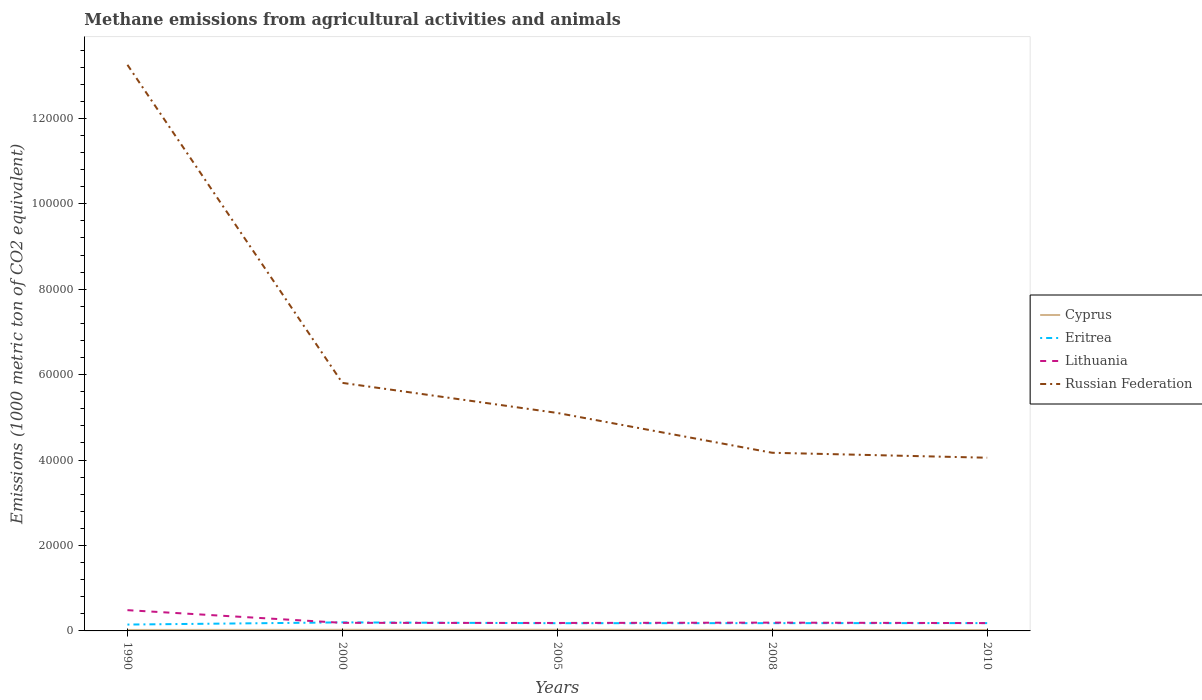Does the line corresponding to Russian Federation intersect with the line corresponding to Cyprus?
Your response must be concise. No. Is the number of lines equal to the number of legend labels?
Your response must be concise. Yes. Across all years, what is the maximum amount of methane emitted in Lithuania?
Keep it short and to the point. 1832.4. What is the total amount of methane emitted in Lithuania in the graph?
Provide a succinct answer. 31.6. What is the difference between the highest and the second highest amount of methane emitted in Cyprus?
Provide a short and direct response. 53.4. Is the amount of methane emitted in Cyprus strictly greater than the amount of methane emitted in Russian Federation over the years?
Offer a terse response. Yes. What is the difference between two consecutive major ticks on the Y-axis?
Give a very brief answer. 2.00e+04. Are the values on the major ticks of Y-axis written in scientific E-notation?
Offer a terse response. No. Does the graph contain any zero values?
Keep it short and to the point. No. Where does the legend appear in the graph?
Offer a very short reply. Center right. How are the legend labels stacked?
Provide a short and direct response. Vertical. What is the title of the graph?
Offer a terse response. Methane emissions from agricultural activities and animals. What is the label or title of the Y-axis?
Make the answer very short. Emissions (1000 metric ton of CO2 equivalent). What is the Emissions (1000 metric ton of CO2 equivalent) of Cyprus in 1990?
Keep it short and to the point. 225.1. What is the Emissions (1000 metric ton of CO2 equivalent) of Eritrea in 1990?
Provide a succinct answer. 1488.1. What is the Emissions (1000 metric ton of CO2 equivalent) in Lithuania in 1990?
Ensure brevity in your answer.  4861.3. What is the Emissions (1000 metric ton of CO2 equivalent) in Russian Federation in 1990?
Your answer should be compact. 1.33e+05. What is the Emissions (1000 metric ton of CO2 equivalent) in Cyprus in 2000?
Your answer should be very brief. 261.7. What is the Emissions (1000 metric ton of CO2 equivalent) of Eritrea in 2000?
Your answer should be compact. 2000.3. What is the Emissions (1000 metric ton of CO2 equivalent) in Lithuania in 2000?
Offer a terse response. 1892.9. What is the Emissions (1000 metric ton of CO2 equivalent) in Russian Federation in 2000?
Give a very brief answer. 5.81e+04. What is the Emissions (1000 metric ton of CO2 equivalent) of Cyprus in 2005?
Your answer should be compact. 271. What is the Emissions (1000 metric ton of CO2 equivalent) of Eritrea in 2005?
Make the answer very short. 1806.6. What is the Emissions (1000 metric ton of CO2 equivalent) of Lithuania in 2005?
Your answer should be compact. 1864. What is the Emissions (1000 metric ton of CO2 equivalent) in Russian Federation in 2005?
Keep it short and to the point. 5.10e+04. What is the Emissions (1000 metric ton of CO2 equivalent) in Cyprus in 2008?
Provide a short and direct response. 231.7. What is the Emissions (1000 metric ton of CO2 equivalent) in Eritrea in 2008?
Offer a very short reply. 1820.8. What is the Emissions (1000 metric ton of CO2 equivalent) of Lithuania in 2008?
Make the answer very short. 1942.5. What is the Emissions (1000 metric ton of CO2 equivalent) in Russian Federation in 2008?
Offer a terse response. 4.17e+04. What is the Emissions (1000 metric ton of CO2 equivalent) of Cyprus in 2010?
Your response must be concise. 217.6. What is the Emissions (1000 metric ton of CO2 equivalent) of Eritrea in 2010?
Give a very brief answer. 1829.8. What is the Emissions (1000 metric ton of CO2 equivalent) of Lithuania in 2010?
Offer a very short reply. 1832.4. What is the Emissions (1000 metric ton of CO2 equivalent) of Russian Federation in 2010?
Your answer should be very brief. 4.06e+04. Across all years, what is the maximum Emissions (1000 metric ton of CO2 equivalent) of Cyprus?
Give a very brief answer. 271. Across all years, what is the maximum Emissions (1000 metric ton of CO2 equivalent) in Eritrea?
Keep it short and to the point. 2000.3. Across all years, what is the maximum Emissions (1000 metric ton of CO2 equivalent) in Lithuania?
Keep it short and to the point. 4861.3. Across all years, what is the maximum Emissions (1000 metric ton of CO2 equivalent) in Russian Federation?
Make the answer very short. 1.33e+05. Across all years, what is the minimum Emissions (1000 metric ton of CO2 equivalent) in Cyprus?
Offer a very short reply. 217.6. Across all years, what is the minimum Emissions (1000 metric ton of CO2 equivalent) in Eritrea?
Offer a terse response. 1488.1. Across all years, what is the minimum Emissions (1000 metric ton of CO2 equivalent) in Lithuania?
Your answer should be very brief. 1832.4. Across all years, what is the minimum Emissions (1000 metric ton of CO2 equivalent) of Russian Federation?
Ensure brevity in your answer.  4.06e+04. What is the total Emissions (1000 metric ton of CO2 equivalent) in Cyprus in the graph?
Your answer should be very brief. 1207.1. What is the total Emissions (1000 metric ton of CO2 equivalent) of Eritrea in the graph?
Offer a terse response. 8945.6. What is the total Emissions (1000 metric ton of CO2 equivalent) of Lithuania in the graph?
Your answer should be very brief. 1.24e+04. What is the total Emissions (1000 metric ton of CO2 equivalent) of Russian Federation in the graph?
Keep it short and to the point. 3.24e+05. What is the difference between the Emissions (1000 metric ton of CO2 equivalent) in Cyprus in 1990 and that in 2000?
Provide a short and direct response. -36.6. What is the difference between the Emissions (1000 metric ton of CO2 equivalent) in Eritrea in 1990 and that in 2000?
Offer a terse response. -512.2. What is the difference between the Emissions (1000 metric ton of CO2 equivalent) of Lithuania in 1990 and that in 2000?
Offer a very short reply. 2968.4. What is the difference between the Emissions (1000 metric ton of CO2 equivalent) of Russian Federation in 1990 and that in 2000?
Give a very brief answer. 7.45e+04. What is the difference between the Emissions (1000 metric ton of CO2 equivalent) of Cyprus in 1990 and that in 2005?
Give a very brief answer. -45.9. What is the difference between the Emissions (1000 metric ton of CO2 equivalent) of Eritrea in 1990 and that in 2005?
Offer a very short reply. -318.5. What is the difference between the Emissions (1000 metric ton of CO2 equivalent) in Lithuania in 1990 and that in 2005?
Your response must be concise. 2997.3. What is the difference between the Emissions (1000 metric ton of CO2 equivalent) in Russian Federation in 1990 and that in 2005?
Your answer should be very brief. 8.15e+04. What is the difference between the Emissions (1000 metric ton of CO2 equivalent) of Eritrea in 1990 and that in 2008?
Provide a short and direct response. -332.7. What is the difference between the Emissions (1000 metric ton of CO2 equivalent) of Lithuania in 1990 and that in 2008?
Make the answer very short. 2918.8. What is the difference between the Emissions (1000 metric ton of CO2 equivalent) in Russian Federation in 1990 and that in 2008?
Offer a very short reply. 9.08e+04. What is the difference between the Emissions (1000 metric ton of CO2 equivalent) of Cyprus in 1990 and that in 2010?
Give a very brief answer. 7.5. What is the difference between the Emissions (1000 metric ton of CO2 equivalent) of Eritrea in 1990 and that in 2010?
Keep it short and to the point. -341.7. What is the difference between the Emissions (1000 metric ton of CO2 equivalent) of Lithuania in 1990 and that in 2010?
Keep it short and to the point. 3028.9. What is the difference between the Emissions (1000 metric ton of CO2 equivalent) in Russian Federation in 1990 and that in 2010?
Your answer should be compact. 9.20e+04. What is the difference between the Emissions (1000 metric ton of CO2 equivalent) of Eritrea in 2000 and that in 2005?
Make the answer very short. 193.7. What is the difference between the Emissions (1000 metric ton of CO2 equivalent) in Lithuania in 2000 and that in 2005?
Ensure brevity in your answer.  28.9. What is the difference between the Emissions (1000 metric ton of CO2 equivalent) in Russian Federation in 2000 and that in 2005?
Give a very brief answer. 7040. What is the difference between the Emissions (1000 metric ton of CO2 equivalent) in Cyprus in 2000 and that in 2008?
Your response must be concise. 30. What is the difference between the Emissions (1000 metric ton of CO2 equivalent) of Eritrea in 2000 and that in 2008?
Ensure brevity in your answer.  179.5. What is the difference between the Emissions (1000 metric ton of CO2 equivalent) in Lithuania in 2000 and that in 2008?
Offer a very short reply. -49.6. What is the difference between the Emissions (1000 metric ton of CO2 equivalent) of Russian Federation in 2000 and that in 2008?
Provide a short and direct response. 1.64e+04. What is the difference between the Emissions (1000 metric ton of CO2 equivalent) of Cyprus in 2000 and that in 2010?
Make the answer very short. 44.1. What is the difference between the Emissions (1000 metric ton of CO2 equivalent) of Eritrea in 2000 and that in 2010?
Provide a short and direct response. 170.5. What is the difference between the Emissions (1000 metric ton of CO2 equivalent) in Lithuania in 2000 and that in 2010?
Give a very brief answer. 60.5. What is the difference between the Emissions (1000 metric ton of CO2 equivalent) in Russian Federation in 2000 and that in 2010?
Ensure brevity in your answer.  1.75e+04. What is the difference between the Emissions (1000 metric ton of CO2 equivalent) in Cyprus in 2005 and that in 2008?
Offer a very short reply. 39.3. What is the difference between the Emissions (1000 metric ton of CO2 equivalent) in Lithuania in 2005 and that in 2008?
Offer a very short reply. -78.5. What is the difference between the Emissions (1000 metric ton of CO2 equivalent) in Russian Federation in 2005 and that in 2008?
Your answer should be very brief. 9324.6. What is the difference between the Emissions (1000 metric ton of CO2 equivalent) in Cyprus in 2005 and that in 2010?
Provide a short and direct response. 53.4. What is the difference between the Emissions (1000 metric ton of CO2 equivalent) of Eritrea in 2005 and that in 2010?
Offer a very short reply. -23.2. What is the difference between the Emissions (1000 metric ton of CO2 equivalent) of Lithuania in 2005 and that in 2010?
Offer a very short reply. 31.6. What is the difference between the Emissions (1000 metric ton of CO2 equivalent) in Russian Federation in 2005 and that in 2010?
Make the answer very short. 1.05e+04. What is the difference between the Emissions (1000 metric ton of CO2 equivalent) of Lithuania in 2008 and that in 2010?
Your answer should be compact. 110.1. What is the difference between the Emissions (1000 metric ton of CO2 equivalent) in Russian Federation in 2008 and that in 2010?
Provide a short and direct response. 1158.2. What is the difference between the Emissions (1000 metric ton of CO2 equivalent) in Cyprus in 1990 and the Emissions (1000 metric ton of CO2 equivalent) in Eritrea in 2000?
Your answer should be very brief. -1775.2. What is the difference between the Emissions (1000 metric ton of CO2 equivalent) of Cyprus in 1990 and the Emissions (1000 metric ton of CO2 equivalent) of Lithuania in 2000?
Keep it short and to the point. -1667.8. What is the difference between the Emissions (1000 metric ton of CO2 equivalent) in Cyprus in 1990 and the Emissions (1000 metric ton of CO2 equivalent) in Russian Federation in 2000?
Your response must be concise. -5.79e+04. What is the difference between the Emissions (1000 metric ton of CO2 equivalent) of Eritrea in 1990 and the Emissions (1000 metric ton of CO2 equivalent) of Lithuania in 2000?
Ensure brevity in your answer.  -404.8. What is the difference between the Emissions (1000 metric ton of CO2 equivalent) of Eritrea in 1990 and the Emissions (1000 metric ton of CO2 equivalent) of Russian Federation in 2000?
Your response must be concise. -5.66e+04. What is the difference between the Emissions (1000 metric ton of CO2 equivalent) of Lithuania in 1990 and the Emissions (1000 metric ton of CO2 equivalent) of Russian Federation in 2000?
Your answer should be very brief. -5.32e+04. What is the difference between the Emissions (1000 metric ton of CO2 equivalent) of Cyprus in 1990 and the Emissions (1000 metric ton of CO2 equivalent) of Eritrea in 2005?
Keep it short and to the point. -1581.5. What is the difference between the Emissions (1000 metric ton of CO2 equivalent) in Cyprus in 1990 and the Emissions (1000 metric ton of CO2 equivalent) in Lithuania in 2005?
Provide a succinct answer. -1638.9. What is the difference between the Emissions (1000 metric ton of CO2 equivalent) of Cyprus in 1990 and the Emissions (1000 metric ton of CO2 equivalent) of Russian Federation in 2005?
Provide a short and direct response. -5.08e+04. What is the difference between the Emissions (1000 metric ton of CO2 equivalent) in Eritrea in 1990 and the Emissions (1000 metric ton of CO2 equivalent) in Lithuania in 2005?
Offer a terse response. -375.9. What is the difference between the Emissions (1000 metric ton of CO2 equivalent) in Eritrea in 1990 and the Emissions (1000 metric ton of CO2 equivalent) in Russian Federation in 2005?
Your response must be concise. -4.95e+04. What is the difference between the Emissions (1000 metric ton of CO2 equivalent) of Lithuania in 1990 and the Emissions (1000 metric ton of CO2 equivalent) of Russian Federation in 2005?
Offer a very short reply. -4.62e+04. What is the difference between the Emissions (1000 metric ton of CO2 equivalent) of Cyprus in 1990 and the Emissions (1000 metric ton of CO2 equivalent) of Eritrea in 2008?
Keep it short and to the point. -1595.7. What is the difference between the Emissions (1000 metric ton of CO2 equivalent) in Cyprus in 1990 and the Emissions (1000 metric ton of CO2 equivalent) in Lithuania in 2008?
Offer a very short reply. -1717.4. What is the difference between the Emissions (1000 metric ton of CO2 equivalent) in Cyprus in 1990 and the Emissions (1000 metric ton of CO2 equivalent) in Russian Federation in 2008?
Make the answer very short. -4.15e+04. What is the difference between the Emissions (1000 metric ton of CO2 equivalent) in Eritrea in 1990 and the Emissions (1000 metric ton of CO2 equivalent) in Lithuania in 2008?
Give a very brief answer. -454.4. What is the difference between the Emissions (1000 metric ton of CO2 equivalent) of Eritrea in 1990 and the Emissions (1000 metric ton of CO2 equivalent) of Russian Federation in 2008?
Your answer should be compact. -4.02e+04. What is the difference between the Emissions (1000 metric ton of CO2 equivalent) of Lithuania in 1990 and the Emissions (1000 metric ton of CO2 equivalent) of Russian Federation in 2008?
Your answer should be compact. -3.68e+04. What is the difference between the Emissions (1000 metric ton of CO2 equivalent) of Cyprus in 1990 and the Emissions (1000 metric ton of CO2 equivalent) of Eritrea in 2010?
Keep it short and to the point. -1604.7. What is the difference between the Emissions (1000 metric ton of CO2 equivalent) of Cyprus in 1990 and the Emissions (1000 metric ton of CO2 equivalent) of Lithuania in 2010?
Offer a terse response. -1607.3. What is the difference between the Emissions (1000 metric ton of CO2 equivalent) in Cyprus in 1990 and the Emissions (1000 metric ton of CO2 equivalent) in Russian Federation in 2010?
Your answer should be very brief. -4.03e+04. What is the difference between the Emissions (1000 metric ton of CO2 equivalent) of Eritrea in 1990 and the Emissions (1000 metric ton of CO2 equivalent) of Lithuania in 2010?
Give a very brief answer. -344.3. What is the difference between the Emissions (1000 metric ton of CO2 equivalent) of Eritrea in 1990 and the Emissions (1000 metric ton of CO2 equivalent) of Russian Federation in 2010?
Make the answer very short. -3.91e+04. What is the difference between the Emissions (1000 metric ton of CO2 equivalent) in Lithuania in 1990 and the Emissions (1000 metric ton of CO2 equivalent) in Russian Federation in 2010?
Ensure brevity in your answer.  -3.57e+04. What is the difference between the Emissions (1000 metric ton of CO2 equivalent) of Cyprus in 2000 and the Emissions (1000 metric ton of CO2 equivalent) of Eritrea in 2005?
Provide a short and direct response. -1544.9. What is the difference between the Emissions (1000 metric ton of CO2 equivalent) of Cyprus in 2000 and the Emissions (1000 metric ton of CO2 equivalent) of Lithuania in 2005?
Make the answer very short. -1602.3. What is the difference between the Emissions (1000 metric ton of CO2 equivalent) in Cyprus in 2000 and the Emissions (1000 metric ton of CO2 equivalent) in Russian Federation in 2005?
Your answer should be compact. -5.08e+04. What is the difference between the Emissions (1000 metric ton of CO2 equivalent) in Eritrea in 2000 and the Emissions (1000 metric ton of CO2 equivalent) in Lithuania in 2005?
Offer a terse response. 136.3. What is the difference between the Emissions (1000 metric ton of CO2 equivalent) in Eritrea in 2000 and the Emissions (1000 metric ton of CO2 equivalent) in Russian Federation in 2005?
Your response must be concise. -4.90e+04. What is the difference between the Emissions (1000 metric ton of CO2 equivalent) of Lithuania in 2000 and the Emissions (1000 metric ton of CO2 equivalent) of Russian Federation in 2005?
Your response must be concise. -4.91e+04. What is the difference between the Emissions (1000 metric ton of CO2 equivalent) in Cyprus in 2000 and the Emissions (1000 metric ton of CO2 equivalent) in Eritrea in 2008?
Offer a very short reply. -1559.1. What is the difference between the Emissions (1000 metric ton of CO2 equivalent) in Cyprus in 2000 and the Emissions (1000 metric ton of CO2 equivalent) in Lithuania in 2008?
Offer a terse response. -1680.8. What is the difference between the Emissions (1000 metric ton of CO2 equivalent) in Cyprus in 2000 and the Emissions (1000 metric ton of CO2 equivalent) in Russian Federation in 2008?
Offer a terse response. -4.14e+04. What is the difference between the Emissions (1000 metric ton of CO2 equivalent) in Eritrea in 2000 and the Emissions (1000 metric ton of CO2 equivalent) in Lithuania in 2008?
Make the answer very short. 57.8. What is the difference between the Emissions (1000 metric ton of CO2 equivalent) in Eritrea in 2000 and the Emissions (1000 metric ton of CO2 equivalent) in Russian Federation in 2008?
Keep it short and to the point. -3.97e+04. What is the difference between the Emissions (1000 metric ton of CO2 equivalent) in Lithuania in 2000 and the Emissions (1000 metric ton of CO2 equivalent) in Russian Federation in 2008?
Your answer should be very brief. -3.98e+04. What is the difference between the Emissions (1000 metric ton of CO2 equivalent) of Cyprus in 2000 and the Emissions (1000 metric ton of CO2 equivalent) of Eritrea in 2010?
Ensure brevity in your answer.  -1568.1. What is the difference between the Emissions (1000 metric ton of CO2 equivalent) in Cyprus in 2000 and the Emissions (1000 metric ton of CO2 equivalent) in Lithuania in 2010?
Your answer should be very brief. -1570.7. What is the difference between the Emissions (1000 metric ton of CO2 equivalent) in Cyprus in 2000 and the Emissions (1000 metric ton of CO2 equivalent) in Russian Federation in 2010?
Your answer should be very brief. -4.03e+04. What is the difference between the Emissions (1000 metric ton of CO2 equivalent) in Eritrea in 2000 and the Emissions (1000 metric ton of CO2 equivalent) in Lithuania in 2010?
Offer a terse response. 167.9. What is the difference between the Emissions (1000 metric ton of CO2 equivalent) in Eritrea in 2000 and the Emissions (1000 metric ton of CO2 equivalent) in Russian Federation in 2010?
Ensure brevity in your answer.  -3.86e+04. What is the difference between the Emissions (1000 metric ton of CO2 equivalent) in Lithuania in 2000 and the Emissions (1000 metric ton of CO2 equivalent) in Russian Federation in 2010?
Your response must be concise. -3.87e+04. What is the difference between the Emissions (1000 metric ton of CO2 equivalent) of Cyprus in 2005 and the Emissions (1000 metric ton of CO2 equivalent) of Eritrea in 2008?
Ensure brevity in your answer.  -1549.8. What is the difference between the Emissions (1000 metric ton of CO2 equivalent) in Cyprus in 2005 and the Emissions (1000 metric ton of CO2 equivalent) in Lithuania in 2008?
Keep it short and to the point. -1671.5. What is the difference between the Emissions (1000 metric ton of CO2 equivalent) of Cyprus in 2005 and the Emissions (1000 metric ton of CO2 equivalent) of Russian Federation in 2008?
Offer a very short reply. -4.14e+04. What is the difference between the Emissions (1000 metric ton of CO2 equivalent) in Eritrea in 2005 and the Emissions (1000 metric ton of CO2 equivalent) in Lithuania in 2008?
Keep it short and to the point. -135.9. What is the difference between the Emissions (1000 metric ton of CO2 equivalent) of Eritrea in 2005 and the Emissions (1000 metric ton of CO2 equivalent) of Russian Federation in 2008?
Ensure brevity in your answer.  -3.99e+04. What is the difference between the Emissions (1000 metric ton of CO2 equivalent) in Lithuania in 2005 and the Emissions (1000 metric ton of CO2 equivalent) in Russian Federation in 2008?
Ensure brevity in your answer.  -3.98e+04. What is the difference between the Emissions (1000 metric ton of CO2 equivalent) in Cyprus in 2005 and the Emissions (1000 metric ton of CO2 equivalent) in Eritrea in 2010?
Your answer should be compact. -1558.8. What is the difference between the Emissions (1000 metric ton of CO2 equivalent) in Cyprus in 2005 and the Emissions (1000 metric ton of CO2 equivalent) in Lithuania in 2010?
Keep it short and to the point. -1561.4. What is the difference between the Emissions (1000 metric ton of CO2 equivalent) of Cyprus in 2005 and the Emissions (1000 metric ton of CO2 equivalent) of Russian Federation in 2010?
Give a very brief answer. -4.03e+04. What is the difference between the Emissions (1000 metric ton of CO2 equivalent) of Eritrea in 2005 and the Emissions (1000 metric ton of CO2 equivalent) of Lithuania in 2010?
Your answer should be very brief. -25.8. What is the difference between the Emissions (1000 metric ton of CO2 equivalent) of Eritrea in 2005 and the Emissions (1000 metric ton of CO2 equivalent) of Russian Federation in 2010?
Your answer should be very brief. -3.87e+04. What is the difference between the Emissions (1000 metric ton of CO2 equivalent) in Lithuania in 2005 and the Emissions (1000 metric ton of CO2 equivalent) in Russian Federation in 2010?
Your response must be concise. -3.87e+04. What is the difference between the Emissions (1000 metric ton of CO2 equivalent) in Cyprus in 2008 and the Emissions (1000 metric ton of CO2 equivalent) in Eritrea in 2010?
Offer a terse response. -1598.1. What is the difference between the Emissions (1000 metric ton of CO2 equivalent) in Cyprus in 2008 and the Emissions (1000 metric ton of CO2 equivalent) in Lithuania in 2010?
Make the answer very short. -1600.7. What is the difference between the Emissions (1000 metric ton of CO2 equivalent) of Cyprus in 2008 and the Emissions (1000 metric ton of CO2 equivalent) of Russian Federation in 2010?
Offer a terse response. -4.03e+04. What is the difference between the Emissions (1000 metric ton of CO2 equivalent) in Eritrea in 2008 and the Emissions (1000 metric ton of CO2 equivalent) in Lithuania in 2010?
Provide a short and direct response. -11.6. What is the difference between the Emissions (1000 metric ton of CO2 equivalent) of Eritrea in 2008 and the Emissions (1000 metric ton of CO2 equivalent) of Russian Federation in 2010?
Offer a terse response. -3.87e+04. What is the difference between the Emissions (1000 metric ton of CO2 equivalent) of Lithuania in 2008 and the Emissions (1000 metric ton of CO2 equivalent) of Russian Federation in 2010?
Ensure brevity in your answer.  -3.86e+04. What is the average Emissions (1000 metric ton of CO2 equivalent) of Cyprus per year?
Keep it short and to the point. 241.42. What is the average Emissions (1000 metric ton of CO2 equivalent) in Eritrea per year?
Offer a terse response. 1789.12. What is the average Emissions (1000 metric ton of CO2 equivalent) of Lithuania per year?
Your answer should be very brief. 2478.62. What is the average Emissions (1000 metric ton of CO2 equivalent) in Russian Federation per year?
Provide a short and direct response. 6.48e+04. In the year 1990, what is the difference between the Emissions (1000 metric ton of CO2 equivalent) of Cyprus and Emissions (1000 metric ton of CO2 equivalent) of Eritrea?
Your answer should be compact. -1263. In the year 1990, what is the difference between the Emissions (1000 metric ton of CO2 equivalent) in Cyprus and Emissions (1000 metric ton of CO2 equivalent) in Lithuania?
Provide a short and direct response. -4636.2. In the year 1990, what is the difference between the Emissions (1000 metric ton of CO2 equivalent) in Cyprus and Emissions (1000 metric ton of CO2 equivalent) in Russian Federation?
Give a very brief answer. -1.32e+05. In the year 1990, what is the difference between the Emissions (1000 metric ton of CO2 equivalent) of Eritrea and Emissions (1000 metric ton of CO2 equivalent) of Lithuania?
Ensure brevity in your answer.  -3373.2. In the year 1990, what is the difference between the Emissions (1000 metric ton of CO2 equivalent) in Eritrea and Emissions (1000 metric ton of CO2 equivalent) in Russian Federation?
Your answer should be compact. -1.31e+05. In the year 1990, what is the difference between the Emissions (1000 metric ton of CO2 equivalent) in Lithuania and Emissions (1000 metric ton of CO2 equivalent) in Russian Federation?
Ensure brevity in your answer.  -1.28e+05. In the year 2000, what is the difference between the Emissions (1000 metric ton of CO2 equivalent) of Cyprus and Emissions (1000 metric ton of CO2 equivalent) of Eritrea?
Give a very brief answer. -1738.6. In the year 2000, what is the difference between the Emissions (1000 metric ton of CO2 equivalent) of Cyprus and Emissions (1000 metric ton of CO2 equivalent) of Lithuania?
Provide a succinct answer. -1631.2. In the year 2000, what is the difference between the Emissions (1000 metric ton of CO2 equivalent) of Cyprus and Emissions (1000 metric ton of CO2 equivalent) of Russian Federation?
Your answer should be compact. -5.78e+04. In the year 2000, what is the difference between the Emissions (1000 metric ton of CO2 equivalent) in Eritrea and Emissions (1000 metric ton of CO2 equivalent) in Lithuania?
Your answer should be very brief. 107.4. In the year 2000, what is the difference between the Emissions (1000 metric ton of CO2 equivalent) of Eritrea and Emissions (1000 metric ton of CO2 equivalent) of Russian Federation?
Provide a short and direct response. -5.61e+04. In the year 2000, what is the difference between the Emissions (1000 metric ton of CO2 equivalent) of Lithuania and Emissions (1000 metric ton of CO2 equivalent) of Russian Federation?
Provide a short and direct response. -5.62e+04. In the year 2005, what is the difference between the Emissions (1000 metric ton of CO2 equivalent) of Cyprus and Emissions (1000 metric ton of CO2 equivalent) of Eritrea?
Ensure brevity in your answer.  -1535.6. In the year 2005, what is the difference between the Emissions (1000 metric ton of CO2 equivalent) of Cyprus and Emissions (1000 metric ton of CO2 equivalent) of Lithuania?
Make the answer very short. -1593. In the year 2005, what is the difference between the Emissions (1000 metric ton of CO2 equivalent) of Cyprus and Emissions (1000 metric ton of CO2 equivalent) of Russian Federation?
Provide a short and direct response. -5.08e+04. In the year 2005, what is the difference between the Emissions (1000 metric ton of CO2 equivalent) of Eritrea and Emissions (1000 metric ton of CO2 equivalent) of Lithuania?
Provide a short and direct response. -57.4. In the year 2005, what is the difference between the Emissions (1000 metric ton of CO2 equivalent) of Eritrea and Emissions (1000 metric ton of CO2 equivalent) of Russian Federation?
Provide a short and direct response. -4.92e+04. In the year 2005, what is the difference between the Emissions (1000 metric ton of CO2 equivalent) in Lithuania and Emissions (1000 metric ton of CO2 equivalent) in Russian Federation?
Give a very brief answer. -4.92e+04. In the year 2008, what is the difference between the Emissions (1000 metric ton of CO2 equivalent) in Cyprus and Emissions (1000 metric ton of CO2 equivalent) in Eritrea?
Provide a short and direct response. -1589.1. In the year 2008, what is the difference between the Emissions (1000 metric ton of CO2 equivalent) of Cyprus and Emissions (1000 metric ton of CO2 equivalent) of Lithuania?
Make the answer very short. -1710.8. In the year 2008, what is the difference between the Emissions (1000 metric ton of CO2 equivalent) in Cyprus and Emissions (1000 metric ton of CO2 equivalent) in Russian Federation?
Give a very brief answer. -4.15e+04. In the year 2008, what is the difference between the Emissions (1000 metric ton of CO2 equivalent) in Eritrea and Emissions (1000 metric ton of CO2 equivalent) in Lithuania?
Provide a succinct answer. -121.7. In the year 2008, what is the difference between the Emissions (1000 metric ton of CO2 equivalent) in Eritrea and Emissions (1000 metric ton of CO2 equivalent) in Russian Federation?
Your response must be concise. -3.99e+04. In the year 2008, what is the difference between the Emissions (1000 metric ton of CO2 equivalent) of Lithuania and Emissions (1000 metric ton of CO2 equivalent) of Russian Federation?
Give a very brief answer. -3.98e+04. In the year 2010, what is the difference between the Emissions (1000 metric ton of CO2 equivalent) of Cyprus and Emissions (1000 metric ton of CO2 equivalent) of Eritrea?
Your answer should be compact. -1612.2. In the year 2010, what is the difference between the Emissions (1000 metric ton of CO2 equivalent) in Cyprus and Emissions (1000 metric ton of CO2 equivalent) in Lithuania?
Your answer should be very brief. -1614.8. In the year 2010, what is the difference between the Emissions (1000 metric ton of CO2 equivalent) of Cyprus and Emissions (1000 metric ton of CO2 equivalent) of Russian Federation?
Keep it short and to the point. -4.03e+04. In the year 2010, what is the difference between the Emissions (1000 metric ton of CO2 equivalent) of Eritrea and Emissions (1000 metric ton of CO2 equivalent) of Russian Federation?
Make the answer very short. -3.87e+04. In the year 2010, what is the difference between the Emissions (1000 metric ton of CO2 equivalent) in Lithuania and Emissions (1000 metric ton of CO2 equivalent) in Russian Federation?
Offer a very short reply. -3.87e+04. What is the ratio of the Emissions (1000 metric ton of CO2 equivalent) in Cyprus in 1990 to that in 2000?
Provide a succinct answer. 0.86. What is the ratio of the Emissions (1000 metric ton of CO2 equivalent) in Eritrea in 1990 to that in 2000?
Keep it short and to the point. 0.74. What is the ratio of the Emissions (1000 metric ton of CO2 equivalent) of Lithuania in 1990 to that in 2000?
Make the answer very short. 2.57. What is the ratio of the Emissions (1000 metric ton of CO2 equivalent) in Russian Federation in 1990 to that in 2000?
Offer a very short reply. 2.28. What is the ratio of the Emissions (1000 metric ton of CO2 equivalent) in Cyprus in 1990 to that in 2005?
Provide a short and direct response. 0.83. What is the ratio of the Emissions (1000 metric ton of CO2 equivalent) in Eritrea in 1990 to that in 2005?
Offer a terse response. 0.82. What is the ratio of the Emissions (1000 metric ton of CO2 equivalent) of Lithuania in 1990 to that in 2005?
Offer a very short reply. 2.61. What is the ratio of the Emissions (1000 metric ton of CO2 equivalent) in Russian Federation in 1990 to that in 2005?
Provide a succinct answer. 2.6. What is the ratio of the Emissions (1000 metric ton of CO2 equivalent) of Cyprus in 1990 to that in 2008?
Give a very brief answer. 0.97. What is the ratio of the Emissions (1000 metric ton of CO2 equivalent) of Eritrea in 1990 to that in 2008?
Provide a short and direct response. 0.82. What is the ratio of the Emissions (1000 metric ton of CO2 equivalent) in Lithuania in 1990 to that in 2008?
Offer a terse response. 2.5. What is the ratio of the Emissions (1000 metric ton of CO2 equivalent) of Russian Federation in 1990 to that in 2008?
Provide a succinct answer. 3.18. What is the ratio of the Emissions (1000 metric ton of CO2 equivalent) in Cyprus in 1990 to that in 2010?
Your response must be concise. 1.03. What is the ratio of the Emissions (1000 metric ton of CO2 equivalent) of Eritrea in 1990 to that in 2010?
Ensure brevity in your answer.  0.81. What is the ratio of the Emissions (1000 metric ton of CO2 equivalent) in Lithuania in 1990 to that in 2010?
Your answer should be compact. 2.65. What is the ratio of the Emissions (1000 metric ton of CO2 equivalent) in Russian Federation in 1990 to that in 2010?
Your answer should be very brief. 3.27. What is the ratio of the Emissions (1000 metric ton of CO2 equivalent) of Cyprus in 2000 to that in 2005?
Your response must be concise. 0.97. What is the ratio of the Emissions (1000 metric ton of CO2 equivalent) in Eritrea in 2000 to that in 2005?
Give a very brief answer. 1.11. What is the ratio of the Emissions (1000 metric ton of CO2 equivalent) of Lithuania in 2000 to that in 2005?
Offer a terse response. 1.02. What is the ratio of the Emissions (1000 metric ton of CO2 equivalent) of Russian Federation in 2000 to that in 2005?
Your answer should be compact. 1.14. What is the ratio of the Emissions (1000 metric ton of CO2 equivalent) in Cyprus in 2000 to that in 2008?
Keep it short and to the point. 1.13. What is the ratio of the Emissions (1000 metric ton of CO2 equivalent) in Eritrea in 2000 to that in 2008?
Your response must be concise. 1.1. What is the ratio of the Emissions (1000 metric ton of CO2 equivalent) in Lithuania in 2000 to that in 2008?
Ensure brevity in your answer.  0.97. What is the ratio of the Emissions (1000 metric ton of CO2 equivalent) in Russian Federation in 2000 to that in 2008?
Provide a short and direct response. 1.39. What is the ratio of the Emissions (1000 metric ton of CO2 equivalent) of Cyprus in 2000 to that in 2010?
Your response must be concise. 1.2. What is the ratio of the Emissions (1000 metric ton of CO2 equivalent) of Eritrea in 2000 to that in 2010?
Make the answer very short. 1.09. What is the ratio of the Emissions (1000 metric ton of CO2 equivalent) of Lithuania in 2000 to that in 2010?
Your answer should be very brief. 1.03. What is the ratio of the Emissions (1000 metric ton of CO2 equivalent) in Russian Federation in 2000 to that in 2010?
Offer a very short reply. 1.43. What is the ratio of the Emissions (1000 metric ton of CO2 equivalent) in Cyprus in 2005 to that in 2008?
Your response must be concise. 1.17. What is the ratio of the Emissions (1000 metric ton of CO2 equivalent) of Eritrea in 2005 to that in 2008?
Your response must be concise. 0.99. What is the ratio of the Emissions (1000 metric ton of CO2 equivalent) in Lithuania in 2005 to that in 2008?
Provide a short and direct response. 0.96. What is the ratio of the Emissions (1000 metric ton of CO2 equivalent) in Russian Federation in 2005 to that in 2008?
Your answer should be very brief. 1.22. What is the ratio of the Emissions (1000 metric ton of CO2 equivalent) in Cyprus in 2005 to that in 2010?
Offer a terse response. 1.25. What is the ratio of the Emissions (1000 metric ton of CO2 equivalent) in Eritrea in 2005 to that in 2010?
Give a very brief answer. 0.99. What is the ratio of the Emissions (1000 metric ton of CO2 equivalent) of Lithuania in 2005 to that in 2010?
Keep it short and to the point. 1.02. What is the ratio of the Emissions (1000 metric ton of CO2 equivalent) in Russian Federation in 2005 to that in 2010?
Your answer should be very brief. 1.26. What is the ratio of the Emissions (1000 metric ton of CO2 equivalent) of Cyprus in 2008 to that in 2010?
Make the answer very short. 1.06. What is the ratio of the Emissions (1000 metric ton of CO2 equivalent) of Lithuania in 2008 to that in 2010?
Ensure brevity in your answer.  1.06. What is the ratio of the Emissions (1000 metric ton of CO2 equivalent) in Russian Federation in 2008 to that in 2010?
Ensure brevity in your answer.  1.03. What is the difference between the highest and the second highest Emissions (1000 metric ton of CO2 equivalent) in Cyprus?
Your response must be concise. 9.3. What is the difference between the highest and the second highest Emissions (1000 metric ton of CO2 equivalent) of Eritrea?
Your answer should be very brief. 170.5. What is the difference between the highest and the second highest Emissions (1000 metric ton of CO2 equivalent) of Lithuania?
Offer a terse response. 2918.8. What is the difference between the highest and the second highest Emissions (1000 metric ton of CO2 equivalent) of Russian Federation?
Ensure brevity in your answer.  7.45e+04. What is the difference between the highest and the lowest Emissions (1000 metric ton of CO2 equivalent) of Cyprus?
Offer a very short reply. 53.4. What is the difference between the highest and the lowest Emissions (1000 metric ton of CO2 equivalent) in Eritrea?
Your answer should be very brief. 512.2. What is the difference between the highest and the lowest Emissions (1000 metric ton of CO2 equivalent) of Lithuania?
Provide a short and direct response. 3028.9. What is the difference between the highest and the lowest Emissions (1000 metric ton of CO2 equivalent) in Russian Federation?
Give a very brief answer. 9.20e+04. 